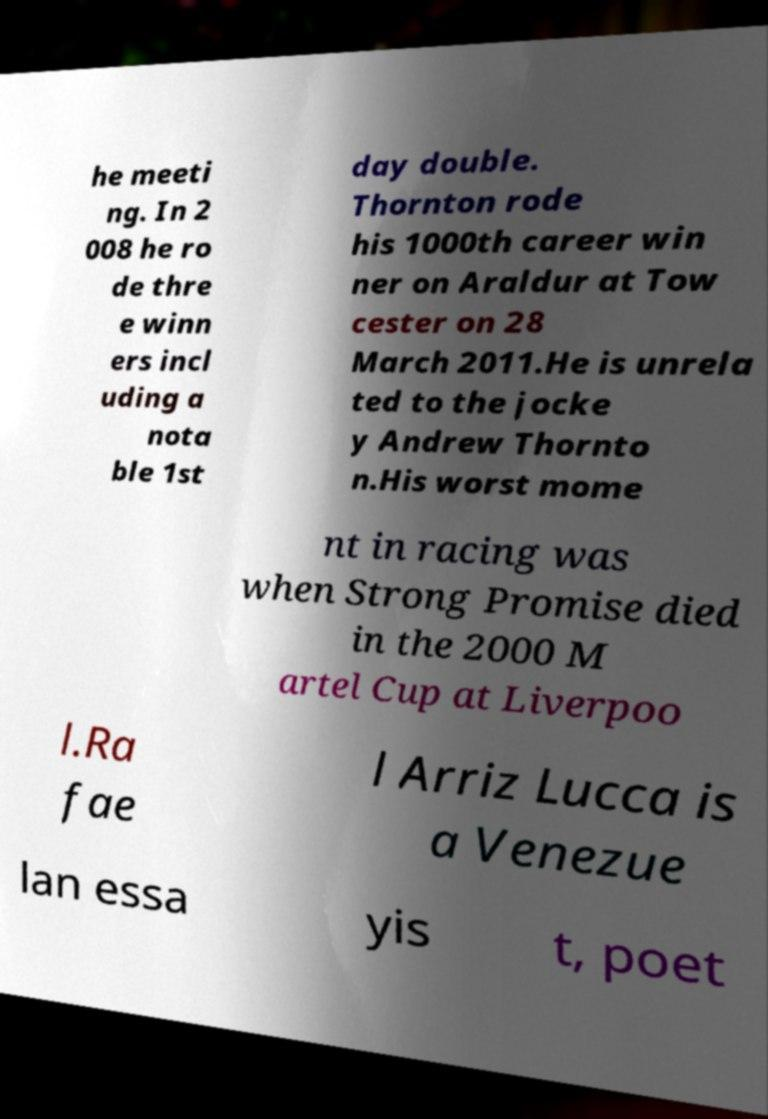Please identify and transcribe the text found in this image. he meeti ng. In 2 008 he ro de thre e winn ers incl uding a nota ble 1st day double. Thornton rode his 1000th career win ner on Araldur at Tow cester on 28 March 2011.He is unrela ted to the jocke y Andrew Thornto n.His worst mome nt in racing was when Strong Promise died in the 2000 M artel Cup at Liverpoo l.Ra fae l Arriz Lucca is a Venezue lan essa yis t, poet 